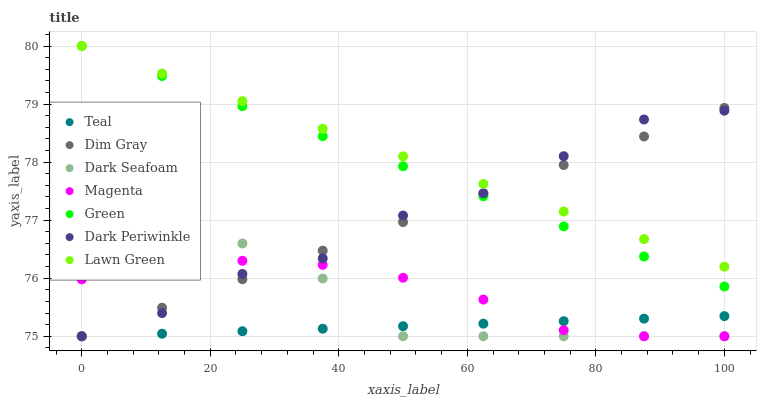Does Teal have the minimum area under the curve?
Answer yes or no. Yes. Does Lawn Green have the maximum area under the curve?
Answer yes or no. Yes. Does Dim Gray have the minimum area under the curve?
Answer yes or no. No. Does Dim Gray have the maximum area under the curve?
Answer yes or no. No. Is Teal the smoothest?
Answer yes or no. Yes. Is Dark Seafoam the roughest?
Answer yes or no. Yes. Is Dim Gray the smoothest?
Answer yes or no. No. Is Dim Gray the roughest?
Answer yes or no. No. Does Dim Gray have the lowest value?
Answer yes or no. Yes. Does Green have the lowest value?
Answer yes or no. No. Does Green have the highest value?
Answer yes or no. Yes. Does Dim Gray have the highest value?
Answer yes or no. No. Is Magenta less than Lawn Green?
Answer yes or no. Yes. Is Lawn Green greater than Magenta?
Answer yes or no. Yes. Does Dim Gray intersect Lawn Green?
Answer yes or no. Yes. Is Dim Gray less than Lawn Green?
Answer yes or no. No. Is Dim Gray greater than Lawn Green?
Answer yes or no. No. Does Magenta intersect Lawn Green?
Answer yes or no. No. 